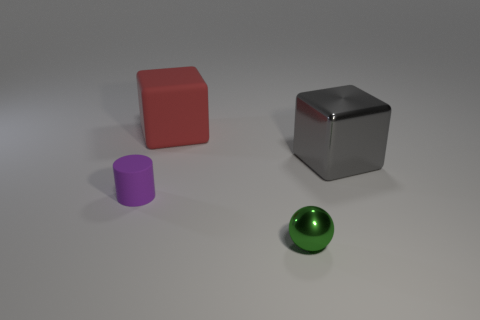Do the metallic object on the right side of the green metal ball and the small matte cylinder have the same size?
Keep it short and to the point. No. There is a block that is the same size as the gray thing; what color is it?
Your answer should be compact. Red. How many gray metal objects are left of the ball?
Provide a succinct answer. 0. Are any big blue shiny cylinders visible?
Keep it short and to the point. No. How big is the rubber thing that is to the right of the thing left of the block that is on the left side of the big metal thing?
Keep it short and to the point. Large. How many other objects are the same size as the gray metal block?
Your answer should be very brief. 1. There is a matte thing left of the large rubber object; how big is it?
Your answer should be very brief. Small. Is there anything else that is the same color as the rubber cylinder?
Provide a succinct answer. No. Does the thing that is in front of the small rubber cylinder have the same material as the big red thing?
Provide a succinct answer. No. How many objects are in front of the red thing and on the left side of the small sphere?
Ensure brevity in your answer.  1. 